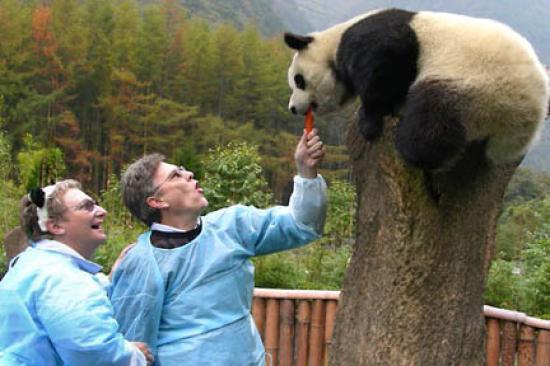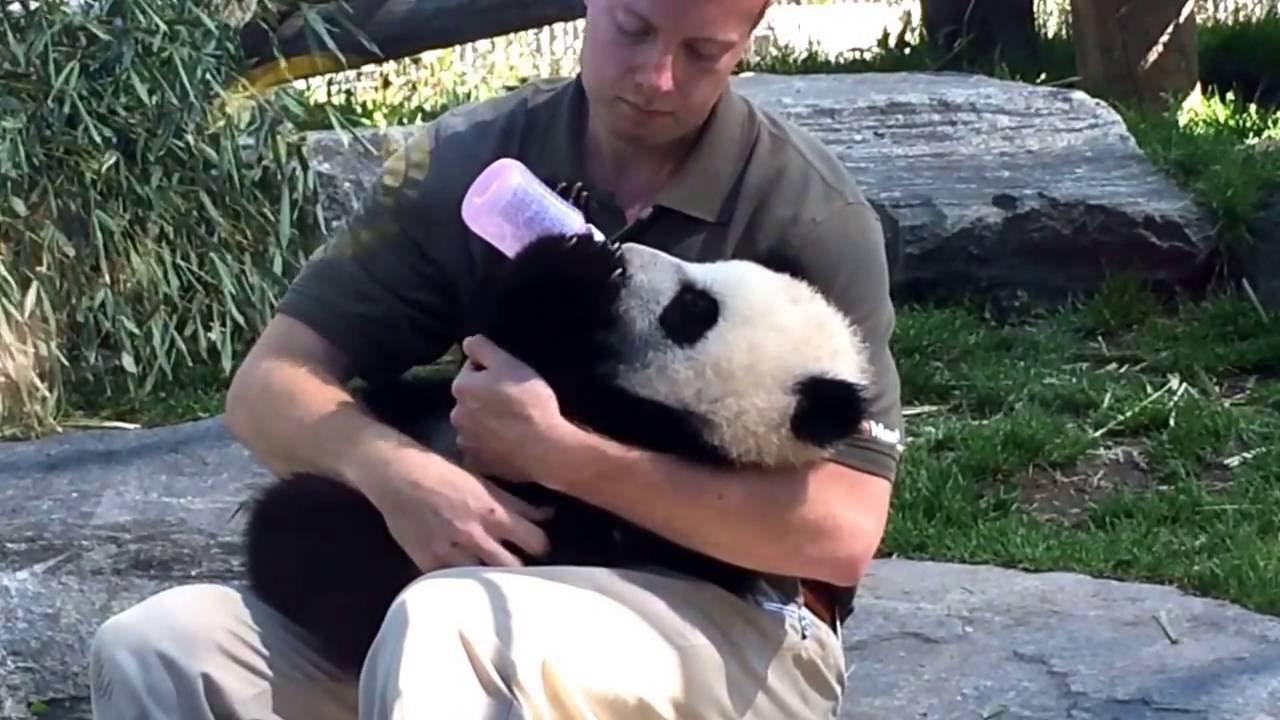The first image is the image on the left, the second image is the image on the right. Examine the images to the left and right. Is the description "In one of the images, there are least two people interacting with a panda bear." accurate? Answer yes or no. Yes. 